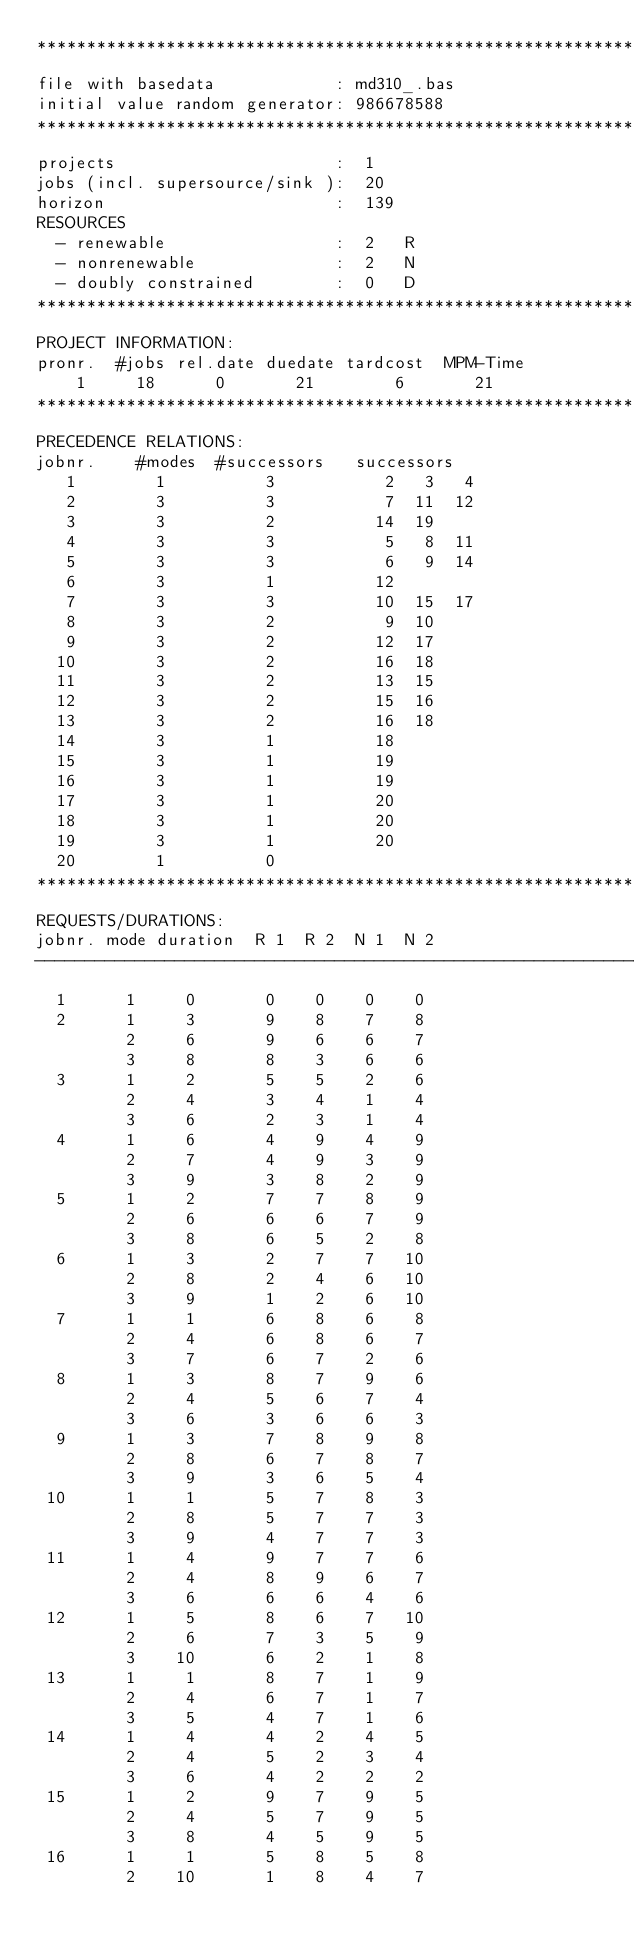<code> <loc_0><loc_0><loc_500><loc_500><_ObjectiveC_>************************************************************************
file with basedata            : md310_.bas
initial value random generator: 986678588
************************************************************************
projects                      :  1
jobs (incl. supersource/sink ):  20
horizon                       :  139
RESOURCES
  - renewable                 :  2   R
  - nonrenewable              :  2   N
  - doubly constrained        :  0   D
************************************************************************
PROJECT INFORMATION:
pronr.  #jobs rel.date duedate tardcost  MPM-Time
    1     18      0       21        6       21
************************************************************************
PRECEDENCE RELATIONS:
jobnr.    #modes  #successors   successors
   1        1          3           2   3   4
   2        3          3           7  11  12
   3        3          2          14  19
   4        3          3           5   8  11
   5        3          3           6   9  14
   6        3          1          12
   7        3          3          10  15  17
   8        3          2           9  10
   9        3          2          12  17
  10        3          2          16  18
  11        3          2          13  15
  12        3          2          15  16
  13        3          2          16  18
  14        3          1          18
  15        3          1          19
  16        3          1          19
  17        3          1          20
  18        3          1          20
  19        3          1          20
  20        1          0        
************************************************************************
REQUESTS/DURATIONS:
jobnr. mode duration  R 1  R 2  N 1  N 2
------------------------------------------------------------------------
  1      1     0       0    0    0    0
  2      1     3       9    8    7    8
         2     6       9    6    6    7
         3     8       8    3    6    6
  3      1     2       5    5    2    6
         2     4       3    4    1    4
         3     6       2    3    1    4
  4      1     6       4    9    4    9
         2     7       4    9    3    9
         3     9       3    8    2    9
  5      1     2       7    7    8    9
         2     6       6    6    7    9
         3     8       6    5    2    8
  6      1     3       2    7    7   10
         2     8       2    4    6   10
         3     9       1    2    6   10
  7      1     1       6    8    6    8
         2     4       6    8    6    7
         3     7       6    7    2    6
  8      1     3       8    7    9    6
         2     4       5    6    7    4
         3     6       3    6    6    3
  9      1     3       7    8    9    8
         2     8       6    7    8    7
         3     9       3    6    5    4
 10      1     1       5    7    8    3
         2     8       5    7    7    3
         3     9       4    7    7    3
 11      1     4       9    7    7    6
         2     4       8    9    6    7
         3     6       6    6    4    6
 12      1     5       8    6    7   10
         2     6       7    3    5    9
         3    10       6    2    1    8
 13      1     1       8    7    1    9
         2     4       6    7    1    7
         3     5       4    7    1    6
 14      1     4       4    2    4    5
         2     4       5    2    3    4
         3     6       4    2    2    2
 15      1     2       9    7    9    5
         2     4       5    7    9    5
         3     8       4    5    9    5
 16      1     1       5    8    5    8
         2    10       1    8    4    7</code> 